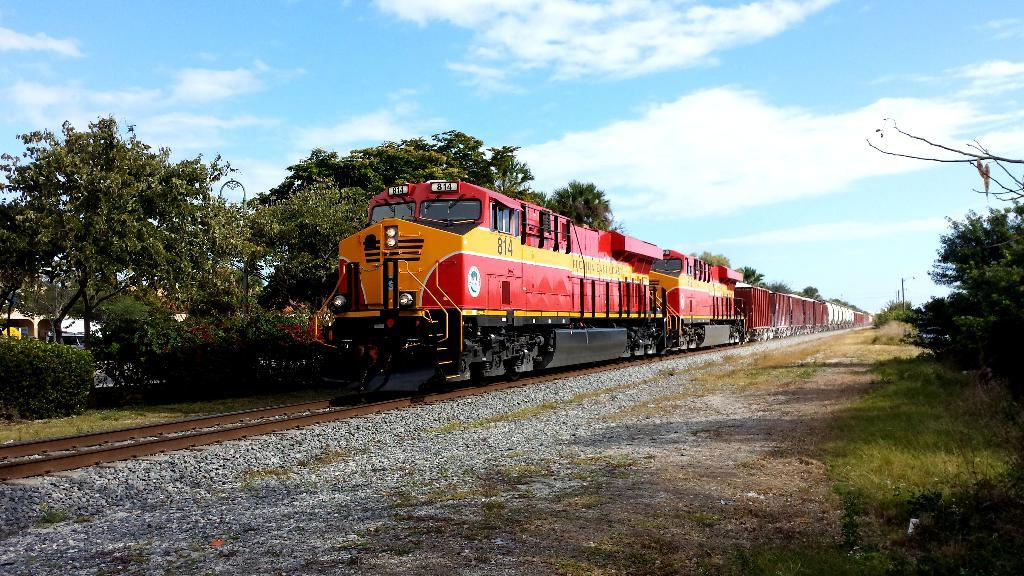What is the main subject of the image? There is a train in the image. Where is the train located? The train is on a railway track. What can be seen in the background of the image? There are trees visible in the image. What else is present in the image besides the train and trees? There are poles in the image. How would you describe the sky in the image? The sky is blue and white in color. What type of quill is being used to write on the train in the image? There is no quill present in the image, and the train is not being used for writing. 